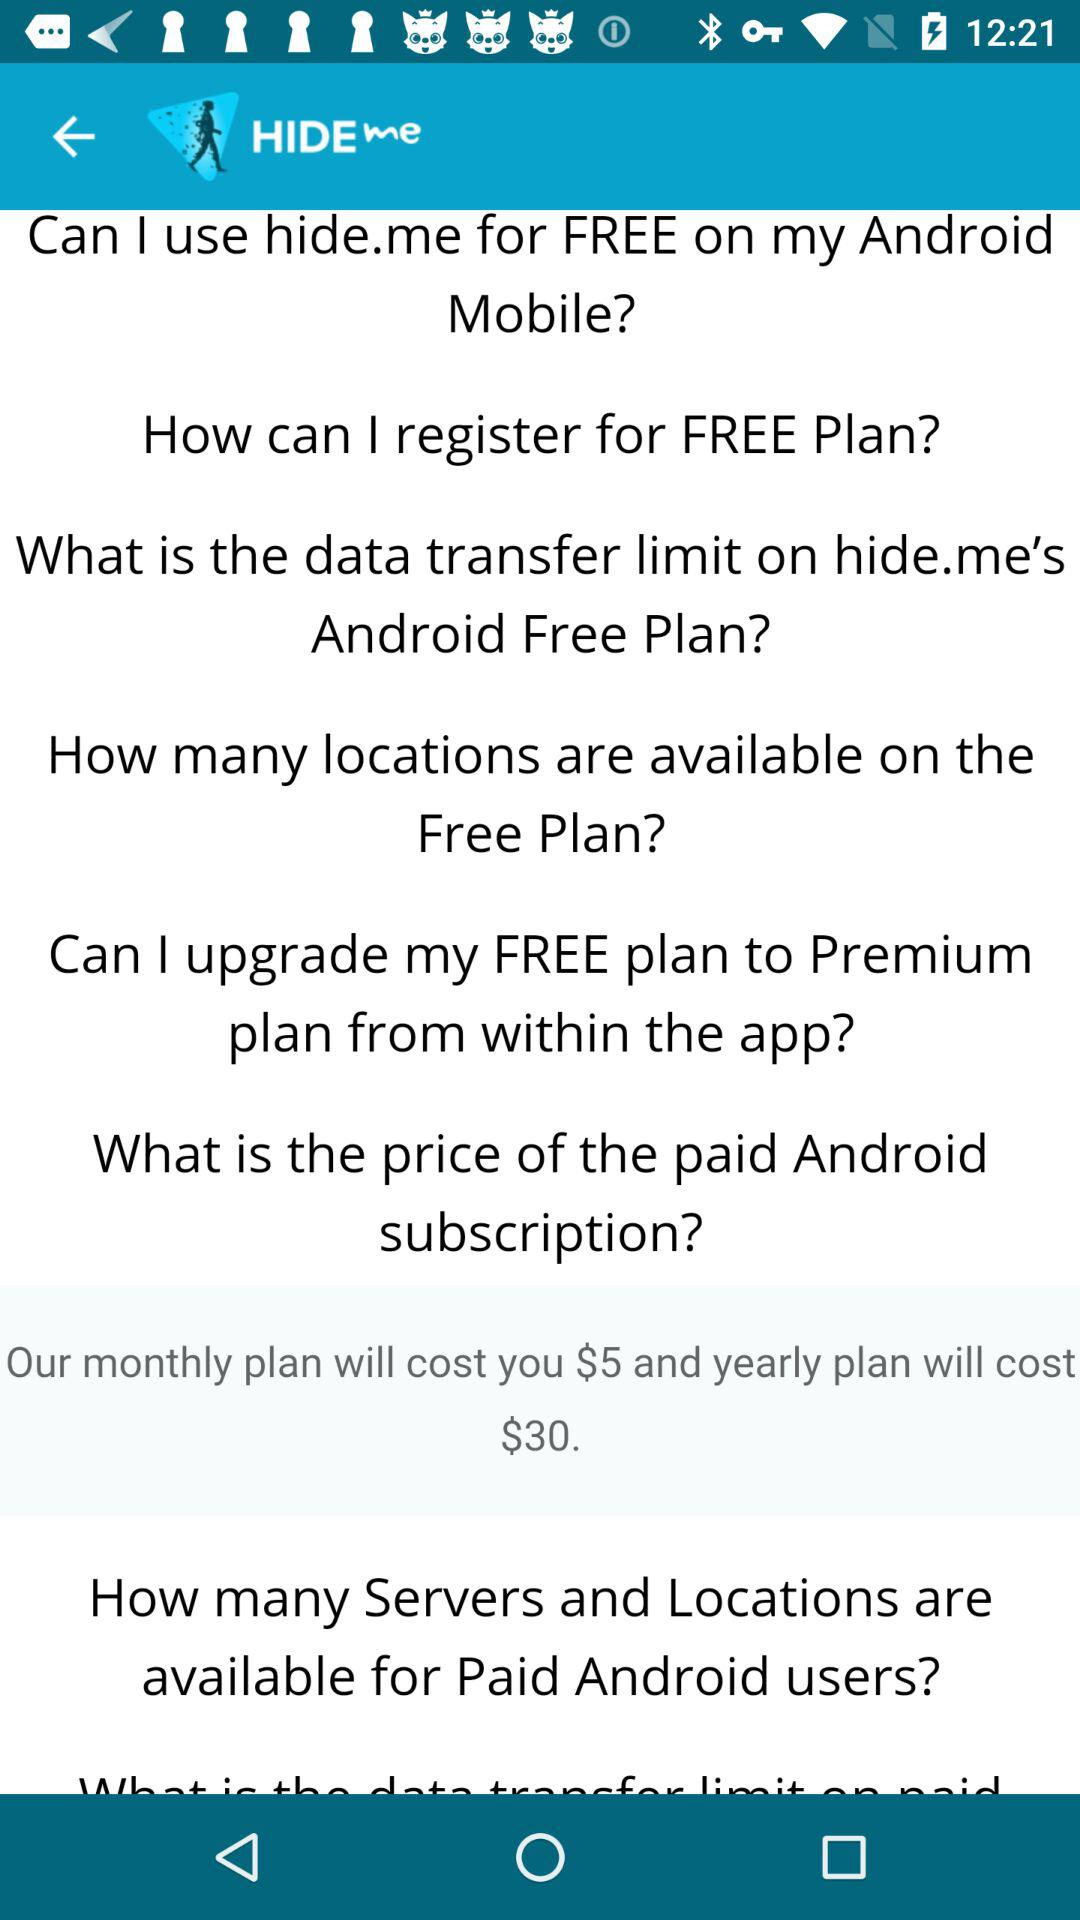What is the cost of a yearly plan? The cost of a yearly plan is $30. 